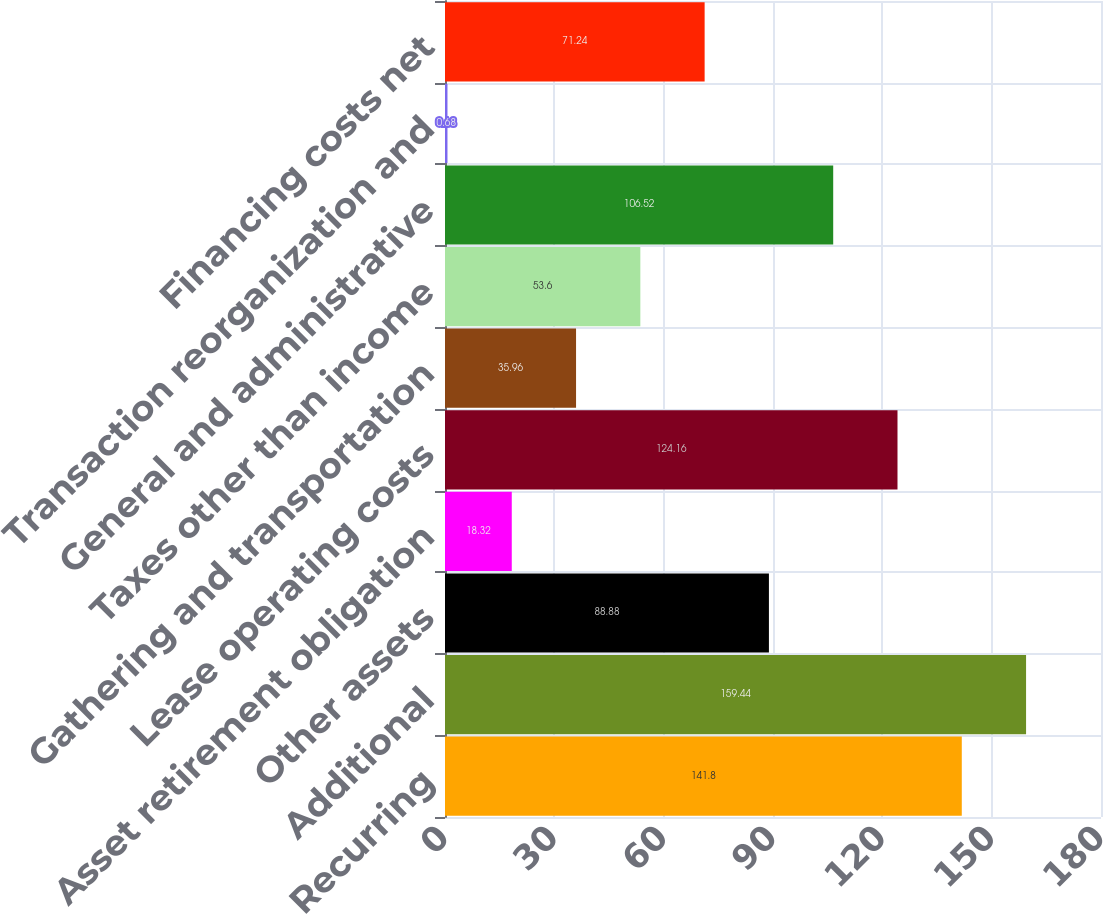<chart> <loc_0><loc_0><loc_500><loc_500><bar_chart><fcel>Recurring<fcel>Additional<fcel>Other assets<fcel>Asset retirement obligation<fcel>Lease operating costs<fcel>Gathering and transportation<fcel>Taxes other than income<fcel>General and administrative<fcel>Transaction reorganization and<fcel>Financing costs net<nl><fcel>141.8<fcel>159.44<fcel>88.88<fcel>18.32<fcel>124.16<fcel>35.96<fcel>53.6<fcel>106.52<fcel>0.68<fcel>71.24<nl></chart> 